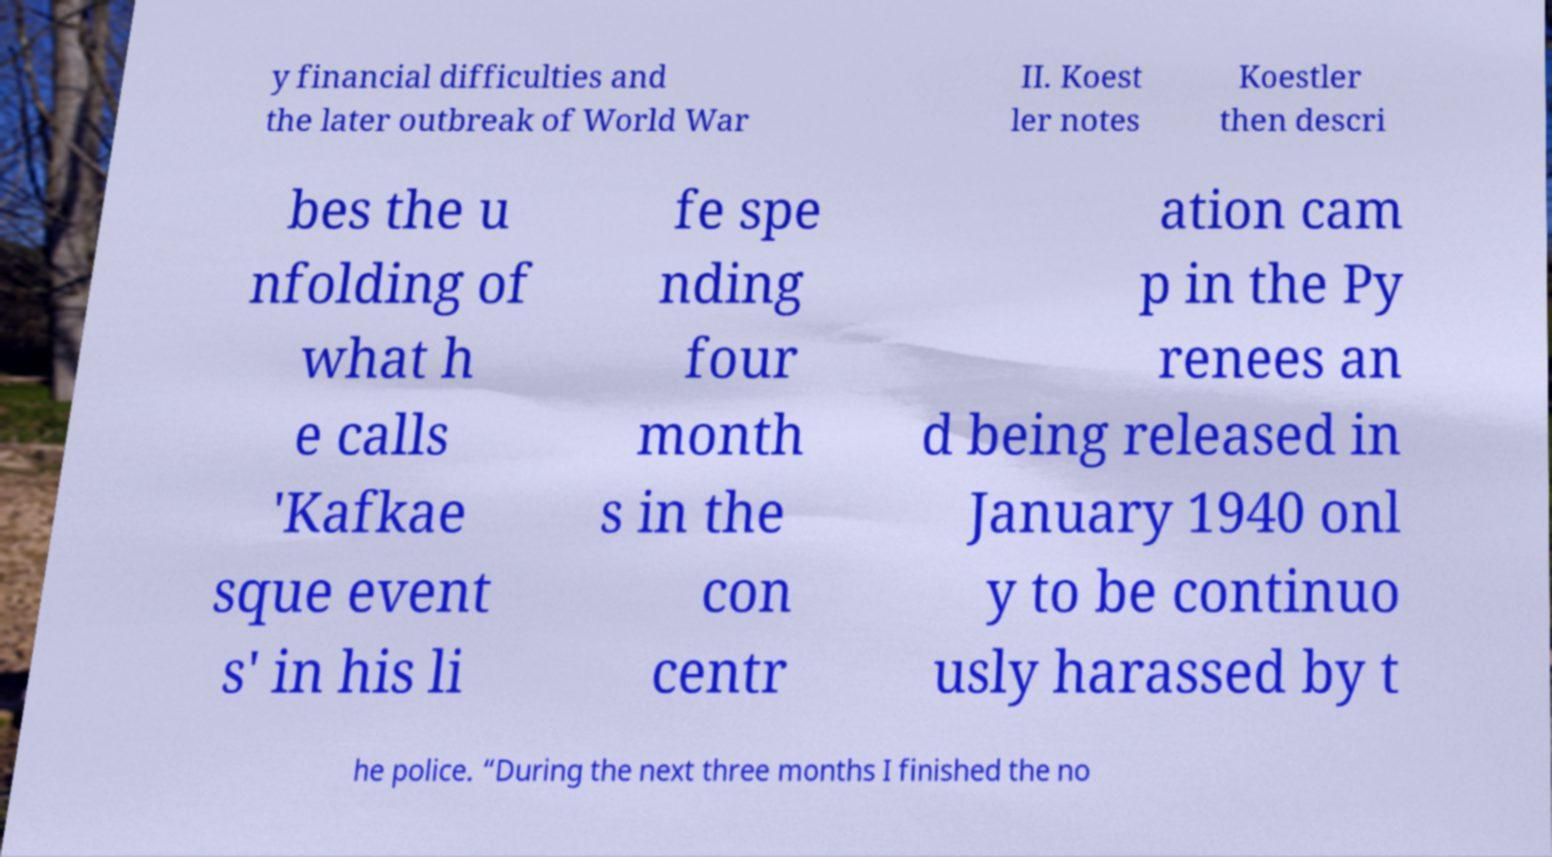What messages or text are displayed in this image? I need them in a readable, typed format. y financial difficulties and the later outbreak of World War II. Koest ler notes Koestler then descri bes the u nfolding of what h e calls 'Kafkae sque event s' in his li fe spe nding four month s in the con centr ation cam p in the Py renees an d being released in January 1940 onl y to be continuo usly harassed by t he police. “During the next three months I finished the no 